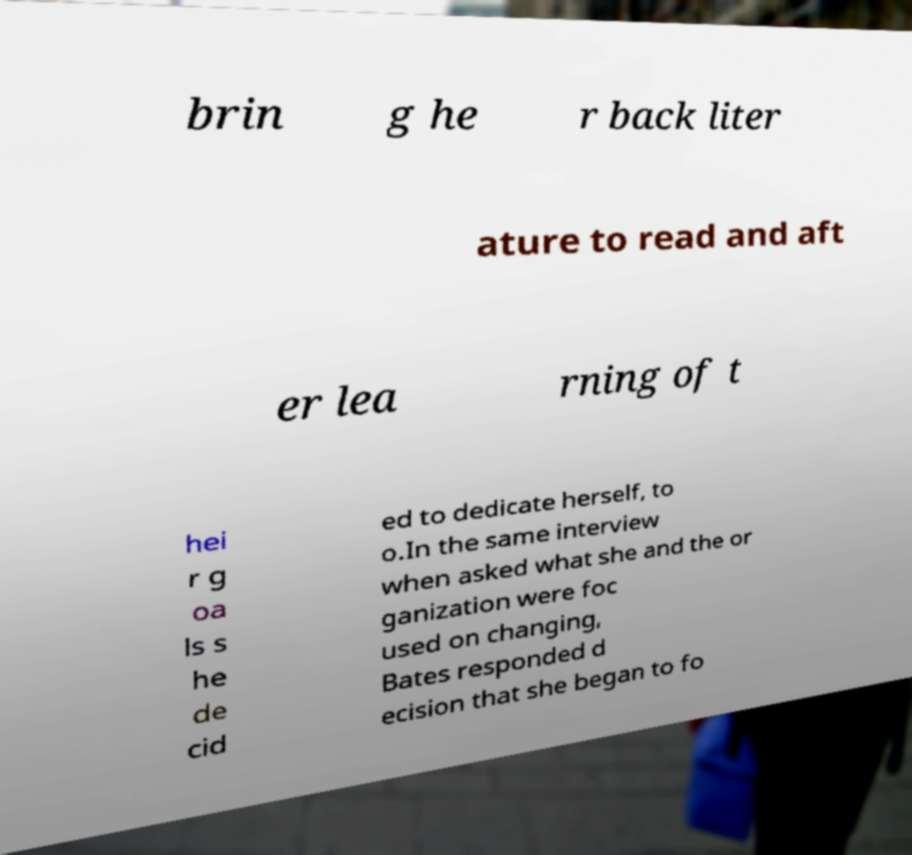Could you extract and type out the text from this image? brin g he r back liter ature to read and aft er lea rning of t hei r g oa ls s he de cid ed to dedicate herself, to o.In the same interview when asked what she and the or ganization were foc used on changing, Bates responded d ecision that she began to fo 